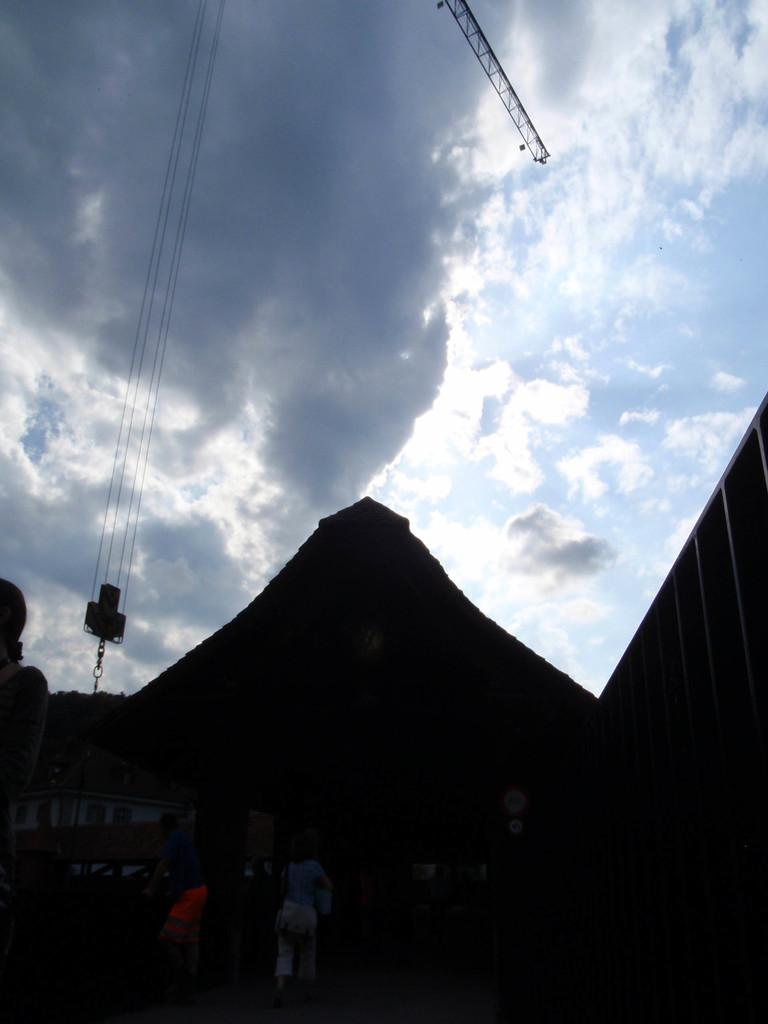What is the lighting condition at the bottom of the image? The bottom of the image is dark. Can you identify any living beings in the image? Yes, there are people visible in the image. What type of structure can be seen in the image? There is a house in the image. What else can be found in the image besides the house and people? There are objects in the image. What can be seen in the sky in the background? There are clouds in the sky in the background. Is there any machinery visible in the background? Yes, there is a crane visible in the background. Where is the sink located in the image? There is no sink present in the image. What type of cable is connected to the crane in the image? There is no cable connected to the crane in the image. 